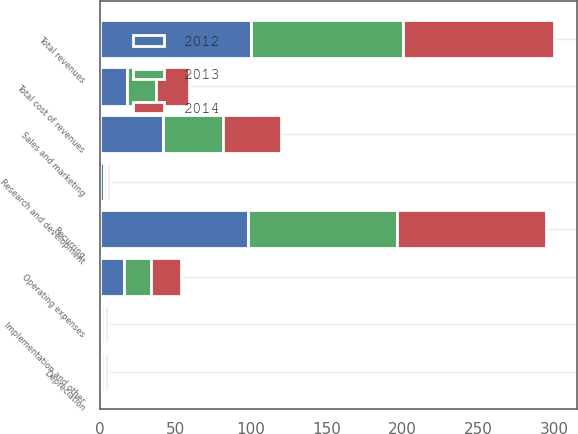<chart> <loc_0><loc_0><loc_500><loc_500><stacked_bar_chart><ecel><fcel>Recurring<fcel>Implementation and other<fcel>Total revenues<fcel>Operating expenses<fcel>Depreciation<fcel>Total cost of revenues<fcel>Sales and marketing<fcel>Research and development<nl><fcel>2012<fcel>98.2<fcel>1.8<fcel>100<fcel>16.4<fcel>1.7<fcel>18.1<fcel>42.1<fcel>2.9<nl><fcel>2013<fcel>98.1<fcel>1.9<fcel>100<fcel>17.7<fcel>1.7<fcel>19.4<fcel>39.7<fcel>2<nl><fcel>2014<fcel>98.2<fcel>1.8<fcel>100<fcel>19.4<fcel>1.9<fcel>21.3<fcel>38.1<fcel>2.1<nl></chart> 